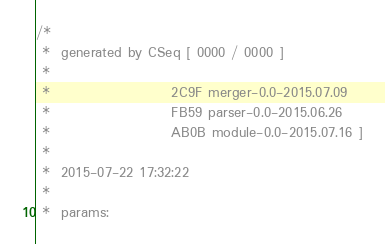<code> <loc_0><loc_0><loc_500><loc_500><_C_>/*
 *  generated by CSeq [ 0000 / 0000 ]
 * 
 *                      2C9F merger-0.0-2015.07.09
 *                      FB59 parser-0.0-2015.06.26
 *                      AB0B module-0.0-2015.07.16 ]
 *
 *  2015-07-22 17:32:22
 *
 *  params:</code> 